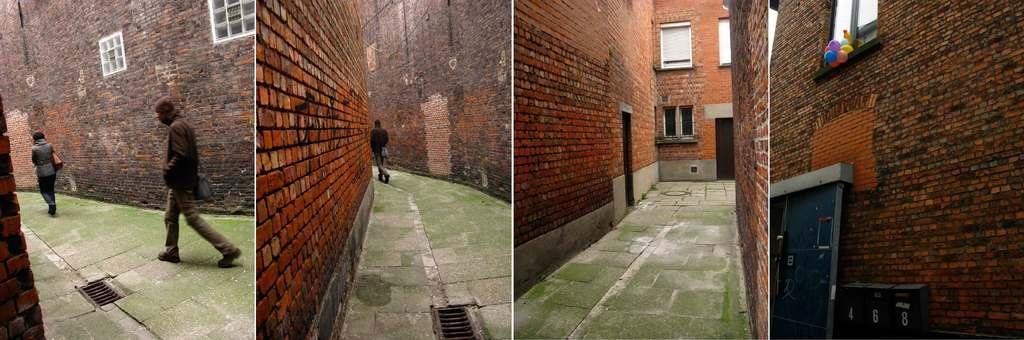Can you describe this image briefly? This is a collage image. We can see the wall with some objects. We can see a few people, balloons and the ground. 